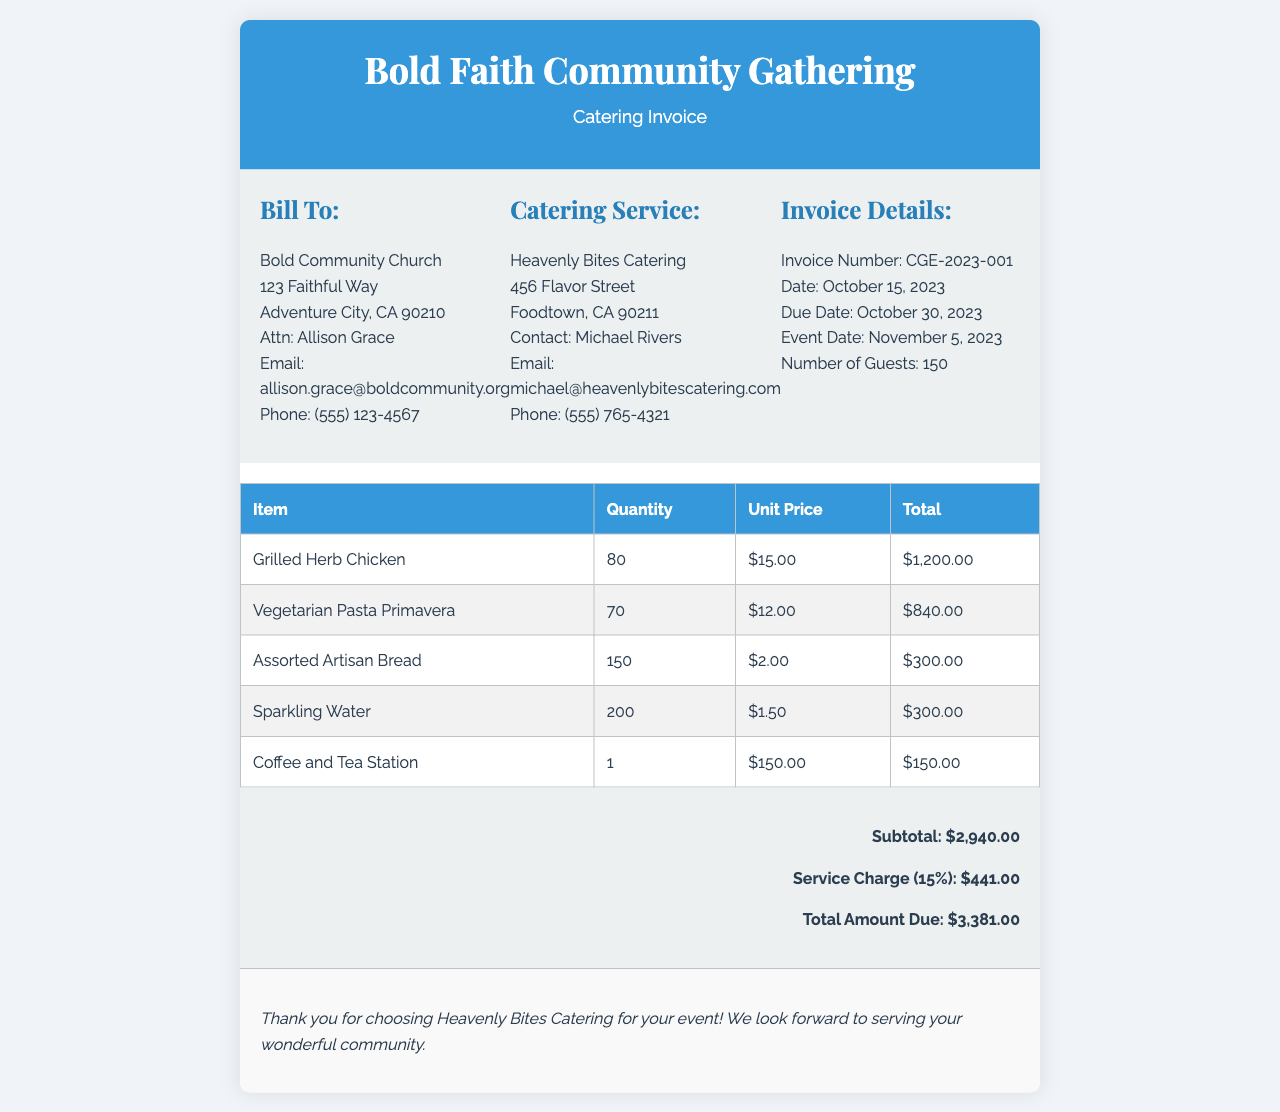What is the invoice number? The invoice number is stated in the invoice details section.
Answer: CGE-2023-001 Who is the contact person for the catering service? The contact person for the catering service is mentioned under Catering Service.
Answer: Michael Rivers What is the total amount due? The total amount due is calculated at the bottom of the invoice.
Answer: $3,381.00 How many guests are expected at the event? The number of guests is indicated in the invoice details.
Answer: 150 What is the service charge percentage? The service charge percentage is referenced in the total amount section.
Answer: 15% What type of pasta is being served? The type of pasta is listed in the invoice table under the food items.
Answer: Vegetarian Pasta Primavera When is the event date? The event date is stated in the invoice details.
Answer: November 5, 2023 What is the unit price of Grilled Herb Chicken? The unit price can be found in the invoice table next to the food item.
Answer: $15.00 What is the subtotal before service charge? The subtotal is given before the service charge calculation.
Answer: $2,940.00 What catering company is handling the event? The name of the catering company is detailed under Catering Service.
Answer: Heavenly Bites Catering 